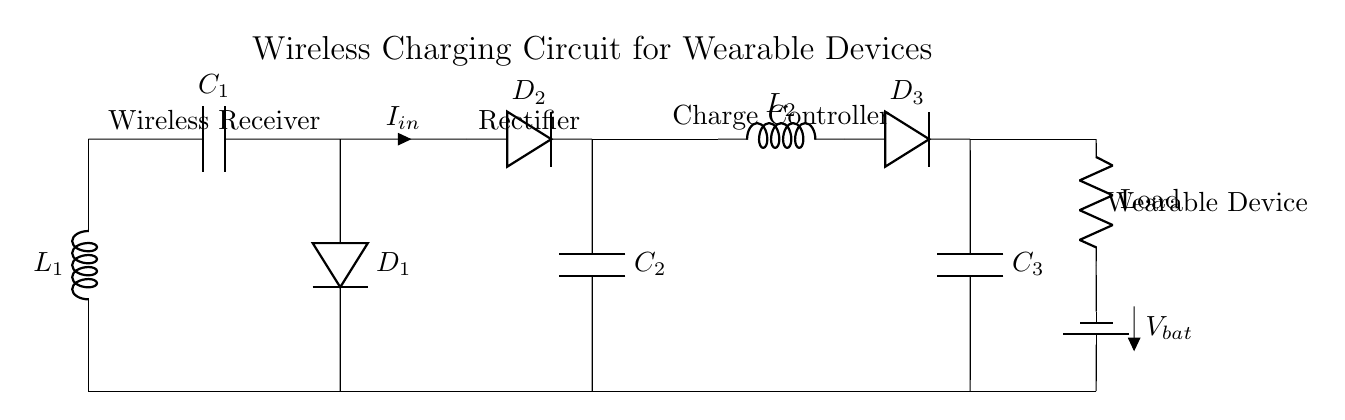What is the first component in the circuit? The first component is an inductor labeled L1, which is positioned at the top left of the circuit diagram.
Answer: L1 What does C1 represent in the circuit? C1 stands for a capacitor in the circuit, specifically the one connected to the inductor L1, used for smoothing the voltage in the wireless charging section.
Answer: Capacitor How many diodes are present in this circuit? There are three diodes labeled D1, D2, and D3. Each diode plays a crucial role in rectifying the alternating current to direct current within the circuit.
Answer: Three What is the function of L2 in the circuit? L2 is an inductor, which is part of the battery charging circuit, and its function is to help manage the current and provide energy storage during the charging process.
Answer: Energy storage What is the voltage of the battery? The voltage of the battery is indicated by the label Vbat, though the specific value isn't provided in this diagram; it represents the battery's potential difference. Ideally, this would be specified by design requirements.
Answer: Vbat What role does the rectifier play in the circuit? The rectifier, represented by diodes D2 and D3, converts the alternating current generated in the wireless charging process into direct current suitable for charging the battery and powering the load.
Answer: Converts AC to DC What would happen if C2 failed in this circuit? If C2 fails, it would disrupt the voltage regulation, likely causing unstable or insufficient voltage to the battery and potentially damaging the wearable device. This is because C2 smooths the output voltage from the rectifier.
Answer: Voltage instability 